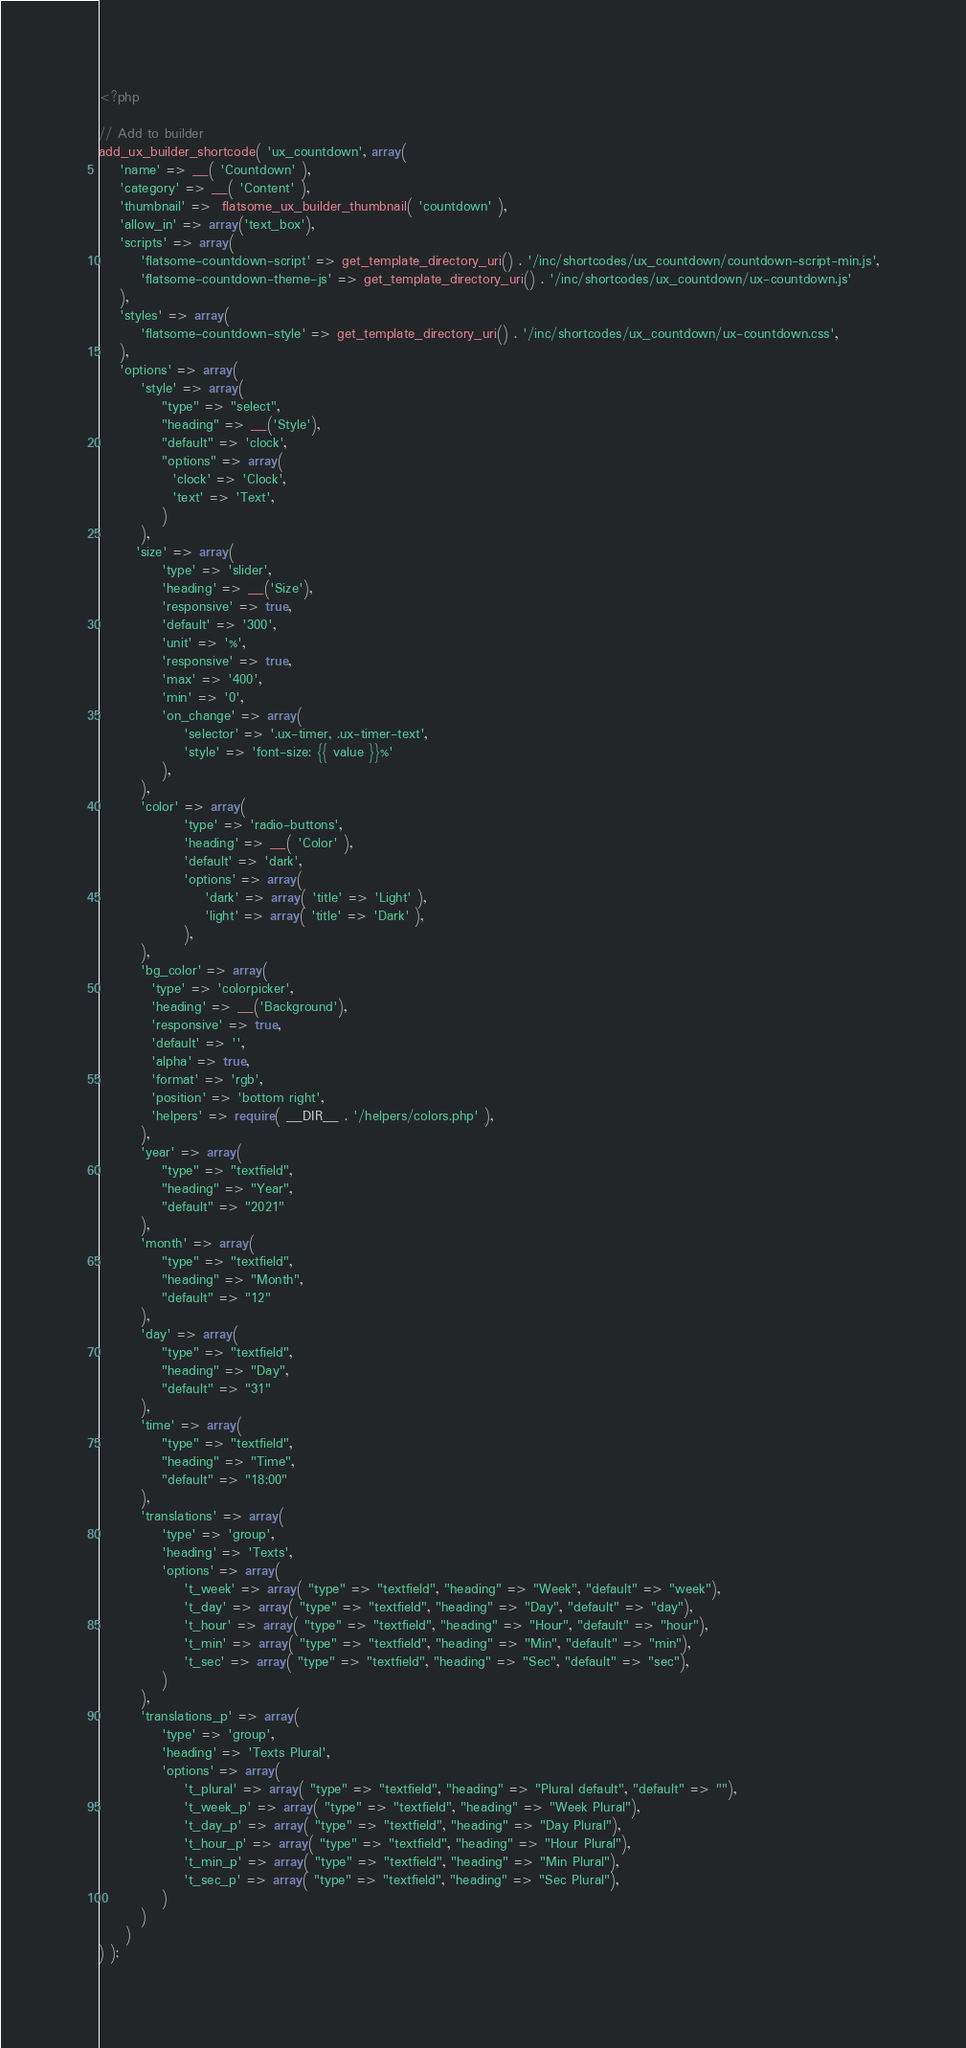<code> <loc_0><loc_0><loc_500><loc_500><_PHP_><?php

// Add to builder
add_ux_builder_shortcode( 'ux_countdown', array(
    'name' => __( 'Countdown' ),
    'category' => __( 'Content' ),
    'thumbnail' =>  flatsome_ux_builder_thumbnail( 'countdown' ),
    'allow_in' => array('text_box'),
    'scripts' => array(
        'flatsome-countdown-script' => get_template_directory_uri() . '/inc/shortcodes/ux_countdown/countdown-script-min.js',
        'flatsome-countdown-theme-js' => get_template_directory_uri() . '/inc/shortcodes/ux_countdown/ux-countdown.js'
    ),
    'styles' => array(
        'flatsome-countdown-style' => get_template_directory_uri() . '/inc/shortcodes/ux_countdown/ux-countdown.css',
    ),
    'options' => array(
        'style' => array(
            "type" => "select",
            "heading" => __('Style'),
            "default" => 'clock',
            "options" => array(
              'clock' => 'Clock',
              'text' => 'Text',
            )
        ),
	   'size' => array(
            'type' => 'slider',
            'heading' => __('Size'),
            'responsive' => true,
            'default' => '300',
            'unit' => '%',
            'responsive' => true,
            'max' => '400',
            'min' => '0',
            'on_change' => array(
                'selector' => '.ux-timer, .ux-timer-text',
                'style' => 'font-size: {{ value }}%'
            ),
        ),
        'color' => array(
                'type' => 'radio-buttons',
                'heading' => __( 'Color' ),
                'default' => 'dark',
                'options' => array(
                    'dark' => array( 'title' => 'Light' ),
                    'light' => array( 'title' => 'Dark' ),
                ),
        ),
        'bg_color' => array(
          'type' => 'colorpicker',
          'heading' => __('Background'),
          'responsive' => true,
          'default' => '',
          'alpha' => true,
          'format' => 'rgb',
          'position' => 'bottom right',
          'helpers' => require( __DIR__ . '/helpers/colors.php' ),
        ),
        'year' => array(
            "type" => "textfield",
            "heading" => "Year",
            "default" => "2021"
        ),
        'month' => array(
            "type" => "textfield",
            "heading" => "Month",
            "default" => "12"
        ),
        'day' => array(
            "type" => "textfield",
            "heading" => "Day",
            "default" => "31"
        ),
        'time' => array(
            "type" => "textfield",
            "heading" => "Time",
            "default" => "18:00"
        ),
        'translations' => array(
            'type' => 'group',
            'heading' => 'Texts',
            'options' => array(
                't_week' => array( "type" => "textfield", "heading" => "Week", "default" => "week"),
                't_day' => array( "type" => "textfield", "heading" => "Day", "default" => "day"),
                't_hour' => array( "type" => "textfield", "heading" => "Hour", "default" => "hour"),
                't_min' => array( "type" => "textfield", "heading" => "Min", "default" => "min"),
                't_sec' => array( "type" => "textfield", "heading" => "Sec", "default" => "sec"),
            )
        ),
        'translations_p' => array(
            'type' => 'group',
            'heading' => 'Texts Plural',
            'options' => array(
                't_plural' => array( "type" => "textfield", "heading" => "Plural default", "default" => ""),
                't_week_p' => array( "type" => "textfield", "heading" => "Week Plural"),
                't_day_p' => array( "type" => "textfield", "heading" => "Day Plural"),
                't_hour_p' => array( "type" => "textfield", "heading" => "Hour Plural"),
                't_min_p' => array( "type" => "textfield", "heading" => "Min Plural"),
                't_sec_p' => array( "type" => "textfield", "heading" => "Sec Plural"),
            )
        )
     )
) );
</code> 